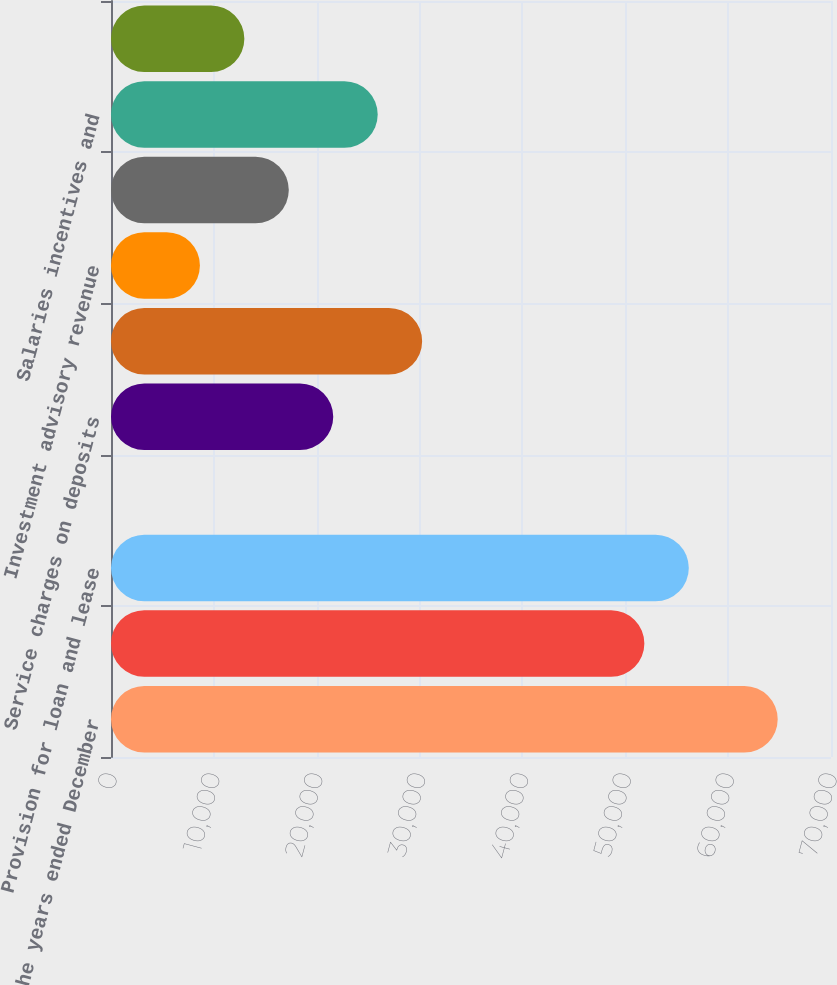<chart> <loc_0><loc_0><loc_500><loc_500><bar_chart><fcel>For the years ended December<fcel>Net interest income (FTE) (a)<fcel>Provision for loan and lease<fcel>Electronic payment processing<fcel>Service charges on deposits<fcel>Corporate banking revenue<fcel>Investment advisory revenue<fcel>Other noninterest income<fcel>Salaries incentives and<fcel>Net occupancy expense<nl><fcel>64818.5<fcel>51855.2<fcel>56176.3<fcel>2<fcel>21607.5<fcel>30249.7<fcel>8644.2<fcel>17286.4<fcel>25928.6<fcel>12965.3<nl></chart> 